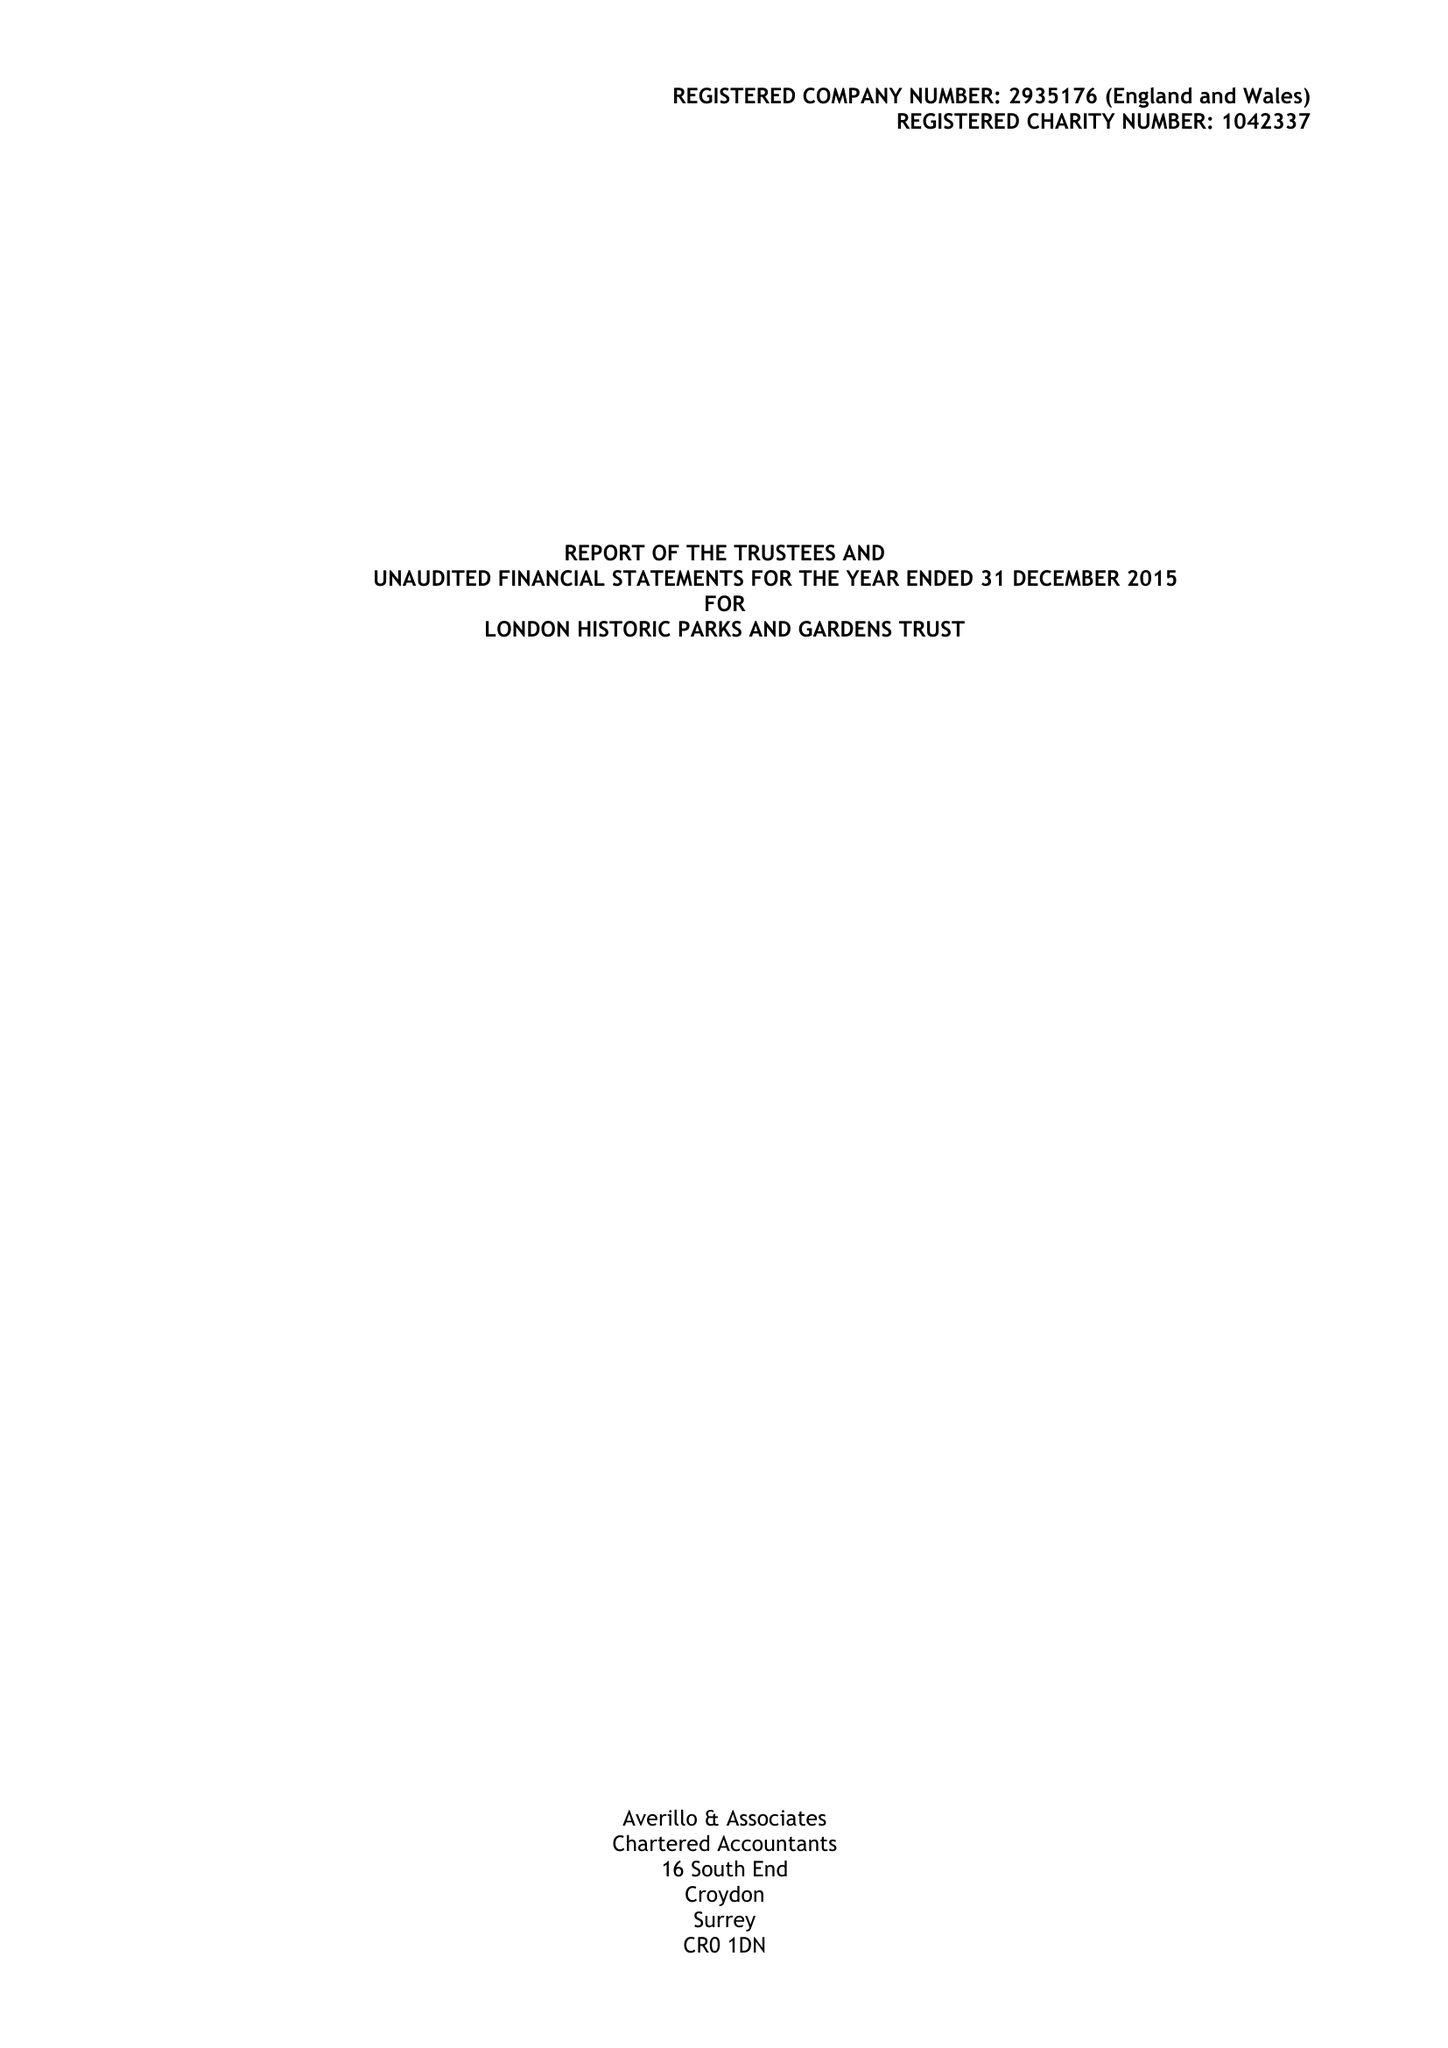What is the value for the report_date?
Answer the question using a single word or phrase. 2015-12-31 